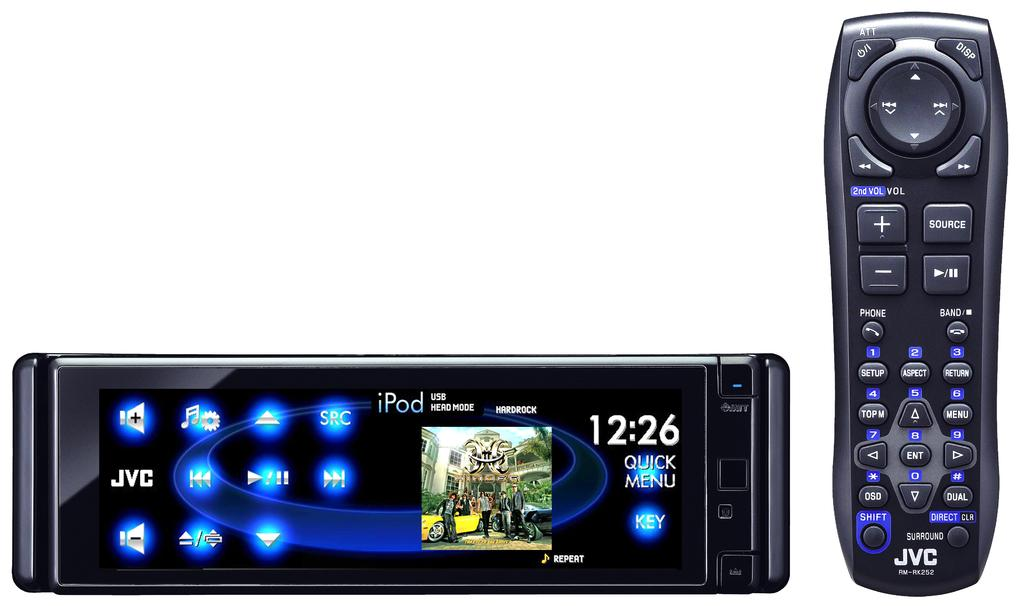Provide a one-sentence caption for the provided image. An Ipod USB Hard Rock remote showing the time as 12:26 next to a conventional remote. 